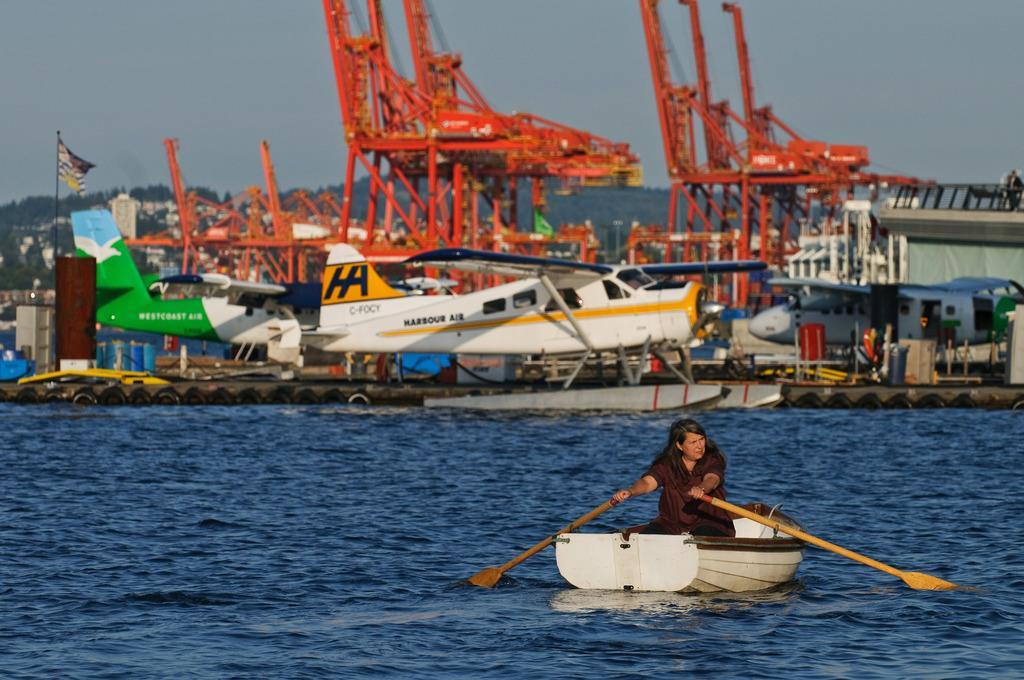Please provide a concise description of this image. In this image we can see a woman sailing a boat. In the background of the image there are gliders, rods, sky, flag. At the bottom of the image there is water. 